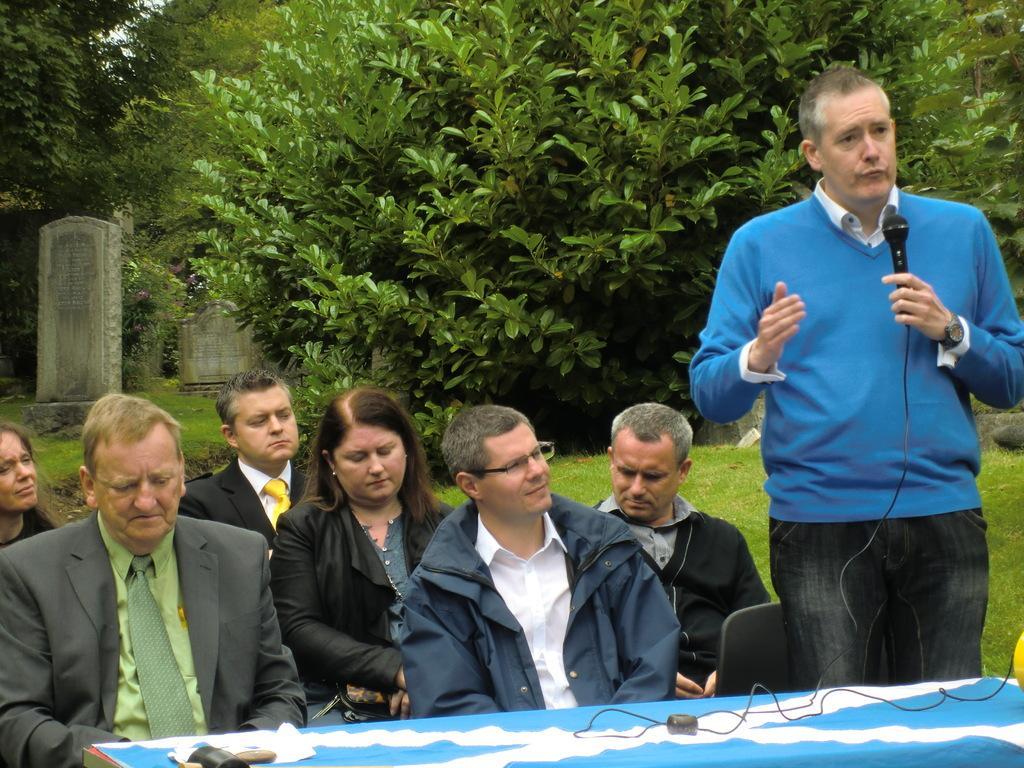In one or two sentences, can you explain what this image depicts? In this picture many people are sitting on the chairs. And there is a table and there is a cloth on the table. A person is standing and talking on the microphone. He wore a watch and he is in blue color T shirt. And here one person is sitting he wore a blue jacket and having spectacles. And on the background there are many trees and there is a grass. And this is the stone. 